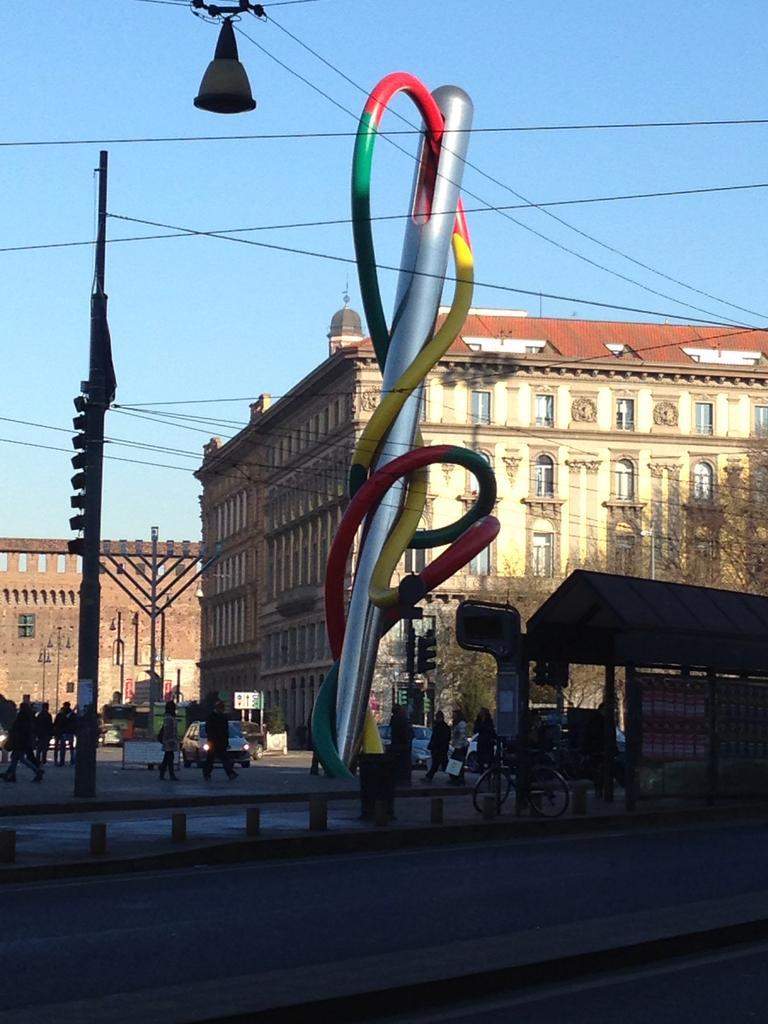Please provide a concise description of this image. This image is clicked on the road. In the front, there are buildings along with windows. And we can see many people on the road. At the top, there is sky. On the right, there is a shed along with trees. 